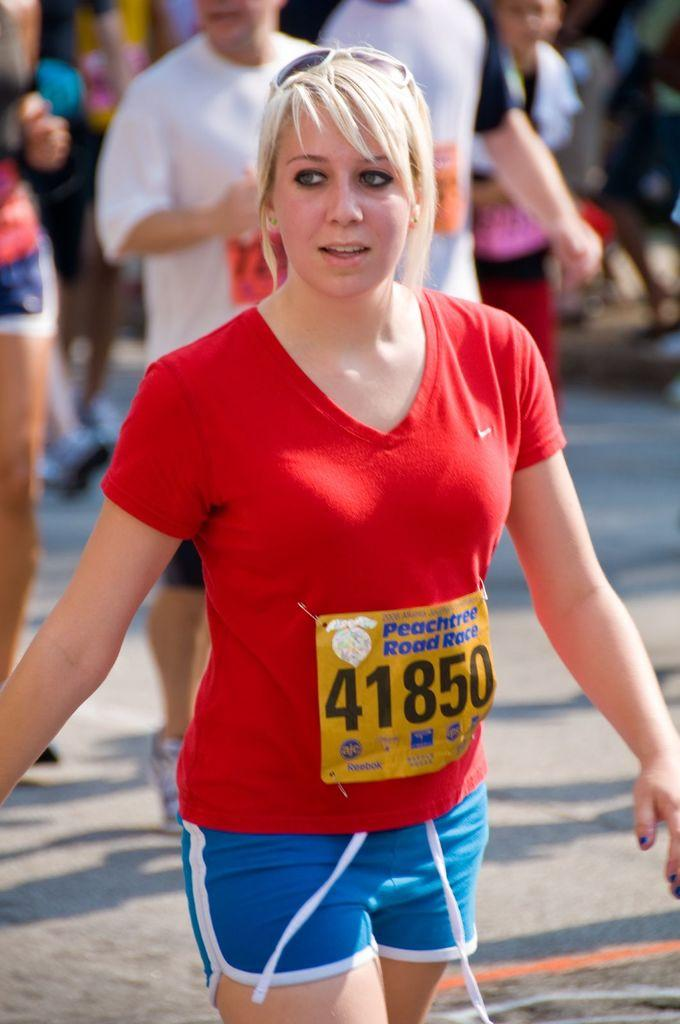<image>
Write a terse but informative summary of the picture. Woman walking for a Peach tree road race wearing the number 41850. 